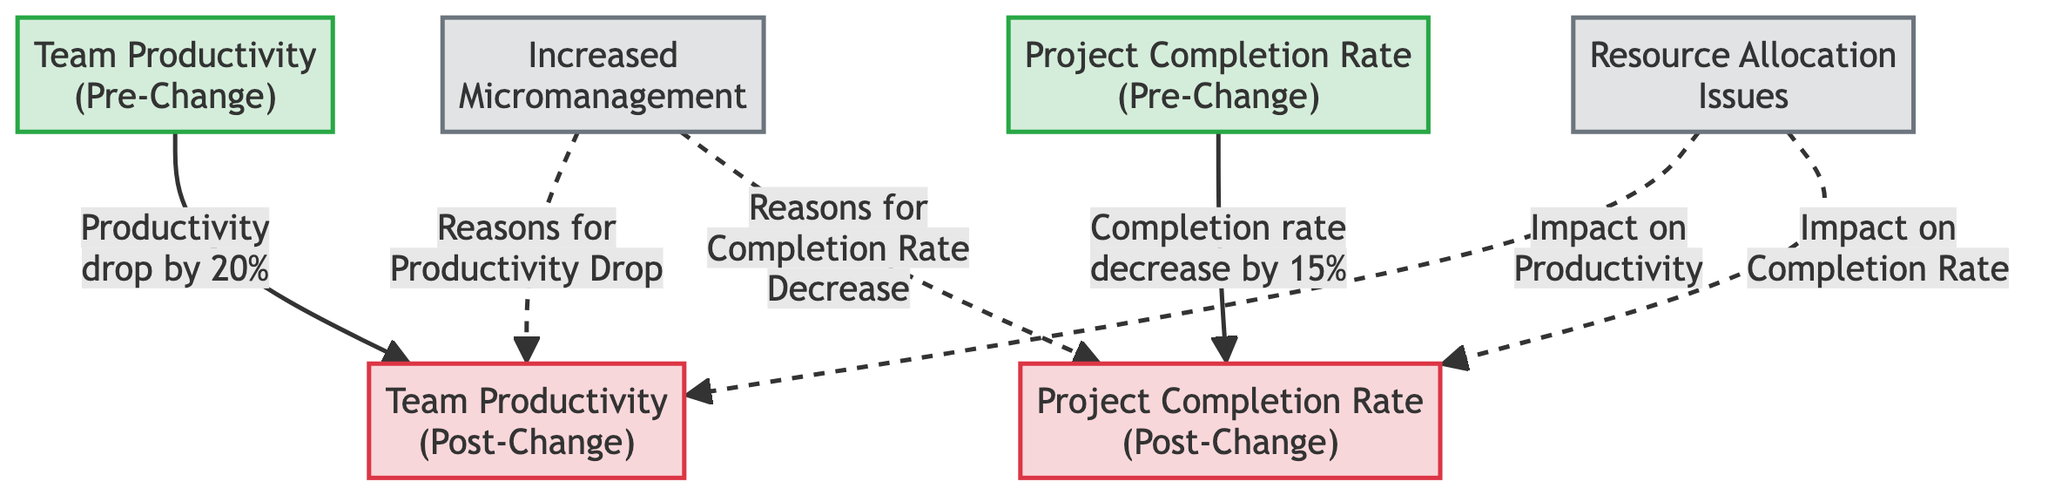What was the percentage drop in team productivity pre- to post-management change? The diagram states that productivity dropped by 20% when comparing pre-change to post-change metrics.
Answer: 20% What was the percentage decrease in project completion rate pre- to post-management change? The diagram illustrates that there was a 15% decrease in project completion rates when moving from pre-change to post-change metrics.
Answer: 15% What type of management practice is indicated as a potential reason for the productivity drop? The diagram labels "Increased Micromanagement" as a potential reason for the observed productivity drop post-management change.
Answer: Increased Micromanagement How many nodes represent the performance metrics in this diagram? By examining the nodes in the diagram, there are a total of four nodes that represent the performance metrics: two for pre-change and two for post-change.
Answer: 4 What is the relationship between increased micromanagement and the project completion rate? The diagram shows that increased micromanagement is connected via a dotted line to the "Project Completion Rate (Post-Change)," indicating it may be a reason for the decrease in that rate.
Answer: Reasons for Completion Rate Decrease What impact does resource allocation issues have on team productivity according to the diagram? The diagram indicates that "Resource Allocation Issues" has a direct influence on team productivity post-management change, as shown by the connection from the reason to the productivity metric.
Answer: Impact on Productivity Which performance metric experienced a decrease of 15%? According to the diagram, the "Project Completion Rate (Post-Change)" shows a decrease of 15% when compared with its pre-change value.
Answer: Completion Rate How many dashed line connections are in the diagram? The diagram features four dashed line connections, representing the reasoning behind the changes in productivity and completion rates.
Answer: 4 What are the two main reasons indicated for the observed trends in productivity and project completion? The diagram lists "Increased Micromanagement" and "Resource Allocation Issues" as the two main reasons for the observed negative trends in both productivity and project completion.
Answer: Increased Micromanagement and Resource Allocation Issues 